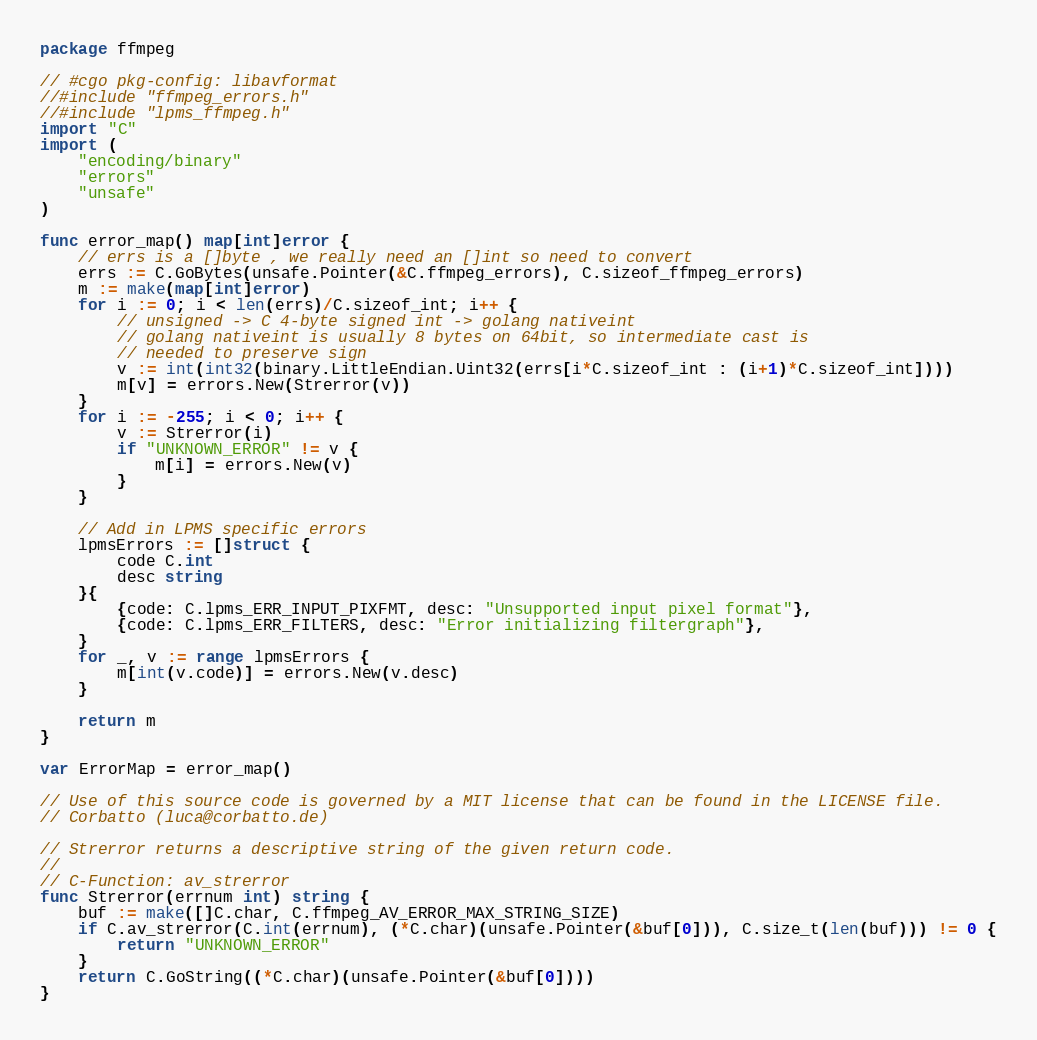Convert code to text. <code><loc_0><loc_0><loc_500><loc_500><_Go_>package ffmpeg

// #cgo pkg-config: libavformat
//#include "ffmpeg_errors.h"
//#include "lpms_ffmpeg.h"
import "C"
import (
	"encoding/binary"
	"errors"
	"unsafe"
)

func error_map() map[int]error {
	// errs is a []byte , we really need an []int so need to convert
	errs := C.GoBytes(unsafe.Pointer(&C.ffmpeg_errors), C.sizeof_ffmpeg_errors)
	m := make(map[int]error)
	for i := 0; i < len(errs)/C.sizeof_int; i++ {
		// unsigned -> C 4-byte signed int -> golang nativeint
		// golang nativeint is usually 8 bytes on 64bit, so intermediate cast is
		// needed to preserve sign
		v := int(int32(binary.LittleEndian.Uint32(errs[i*C.sizeof_int : (i+1)*C.sizeof_int])))
		m[v] = errors.New(Strerror(v))
	}
	for i := -255; i < 0; i++ {
		v := Strerror(i)
		if "UNKNOWN_ERROR" != v {
			m[i] = errors.New(v)
		}
	}

	// Add in LPMS specific errors
	lpmsErrors := []struct {
		code C.int
		desc string
	}{
		{code: C.lpms_ERR_INPUT_PIXFMT, desc: "Unsupported input pixel format"},
		{code: C.lpms_ERR_FILTERS, desc: "Error initializing filtergraph"},
	}
	for _, v := range lpmsErrors {
		m[int(v.code)] = errors.New(v.desc)
	}

	return m
}

var ErrorMap = error_map()

// Use of this source code is governed by a MIT license that can be found in the LICENSE file.
// Corbatto (luca@corbatto.de)

// Strerror returns a descriptive string of the given return code.
//
// C-Function: av_strerror
func Strerror(errnum int) string {
	buf := make([]C.char, C.ffmpeg_AV_ERROR_MAX_STRING_SIZE)
	if C.av_strerror(C.int(errnum), (*C.char)(unsafe.Pointer(&buf[0])), C.size_t(len(buf))) != 0 {
		return "UNKNOWN_ERROR"
	}
	return C.GoString((*C.char)(unsafe.Pointer(&buf[0])))
}
</code> 